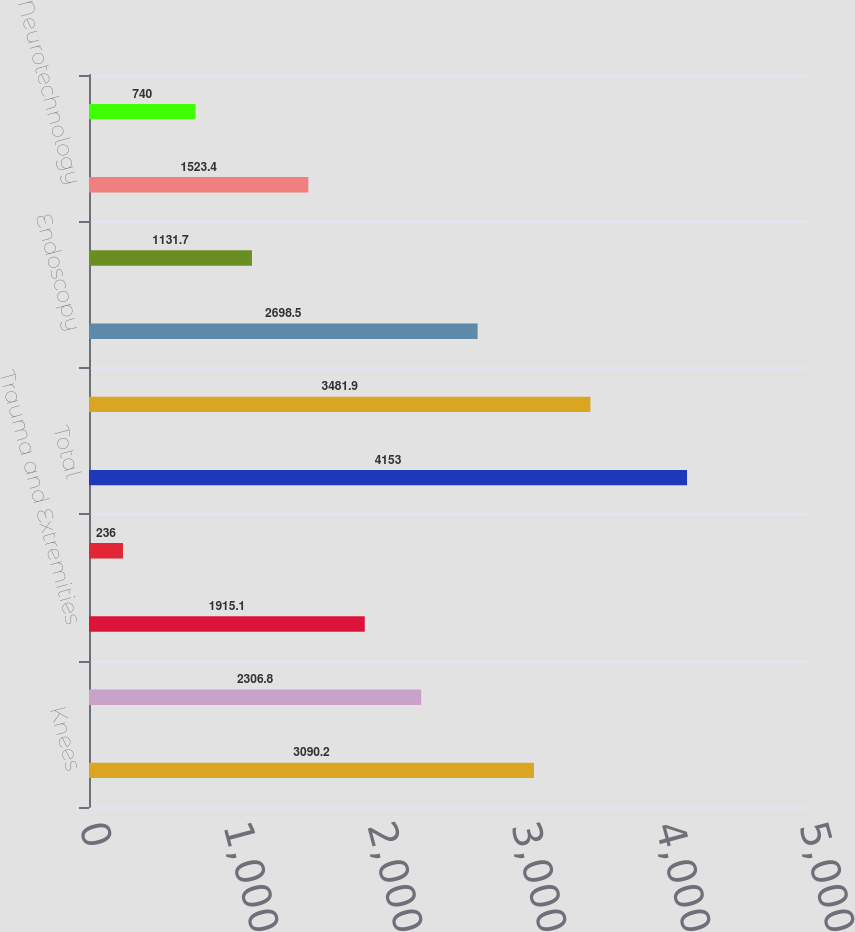Convert chart. <chart><loc_0><loc_0><loc_500><loc_500><bar_chart><fcel>Knees<fcel>Hips<fcel>Trauma and Extremities<fcel>Other<fcel>Total<fcel>Instruments<fcel>Endoscopy<fcel>Medical<fcel>Neurotechnology<fcel>Spine<nl><fcel>3090.2<fcel>2306.8<fcel>1915.1<fcel>236<fcel>4153<fcel>3481.9<fcel>2698.5<fcel>1131.7<fcel>1523.4<fcel>740<nl></chart> 